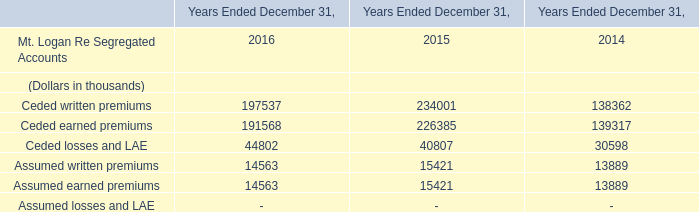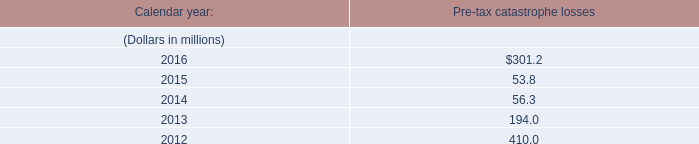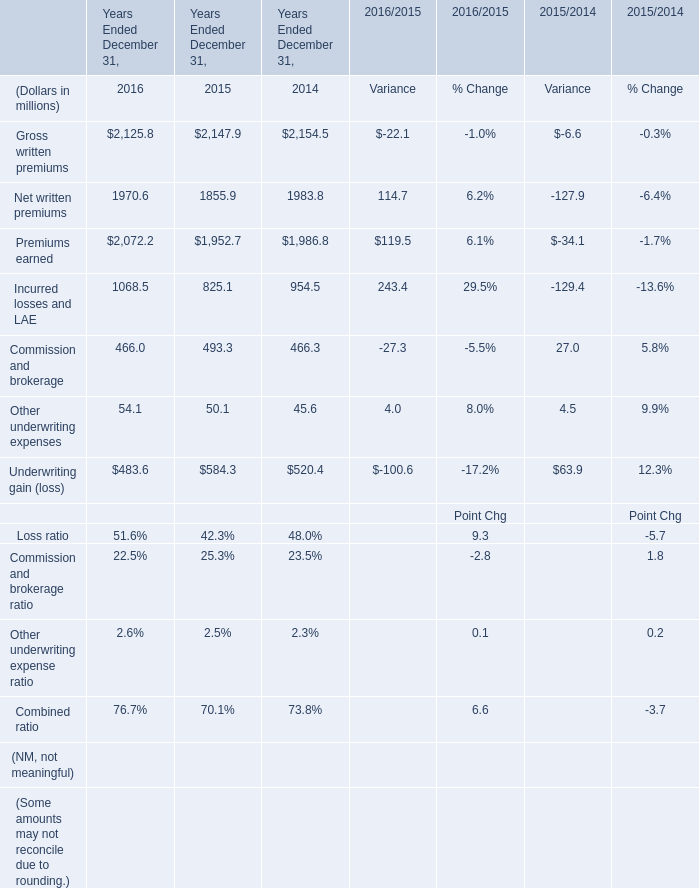What is the total amount of Net written premiums of Years Ended December 31, 2015, and Assumed earned premiums of Years Ended December 31, 2015 ? 
Computations: (1855.9 + 15421.0)
Answer: 17276.9. 